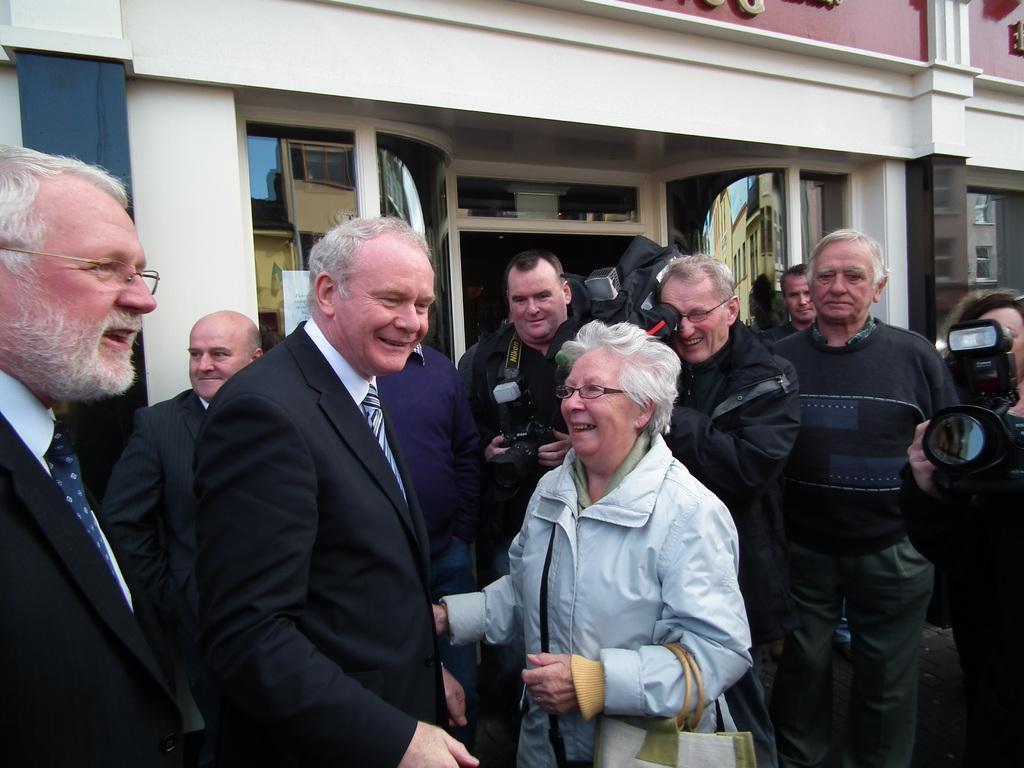How would you summarize this image in a sentence or two? In this image I can see a group of people. In the background, I can see the buildings. 